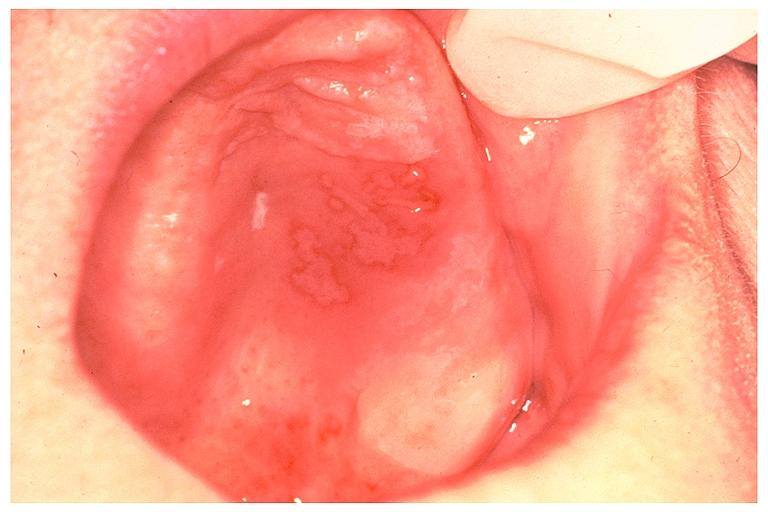does total effacement case show recurrent intraoral herpes simplex?
Answer the question using a single word or phrase. No 